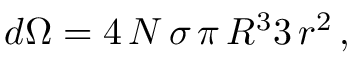<formula> <loc_0><loc_0><loc_500><loc_500>d \Omega = { 4 \, N \, \sigma \, \pi \, R ^ { 3 } } { 3 \, r ^ { 2 } } \, ,</formula> 